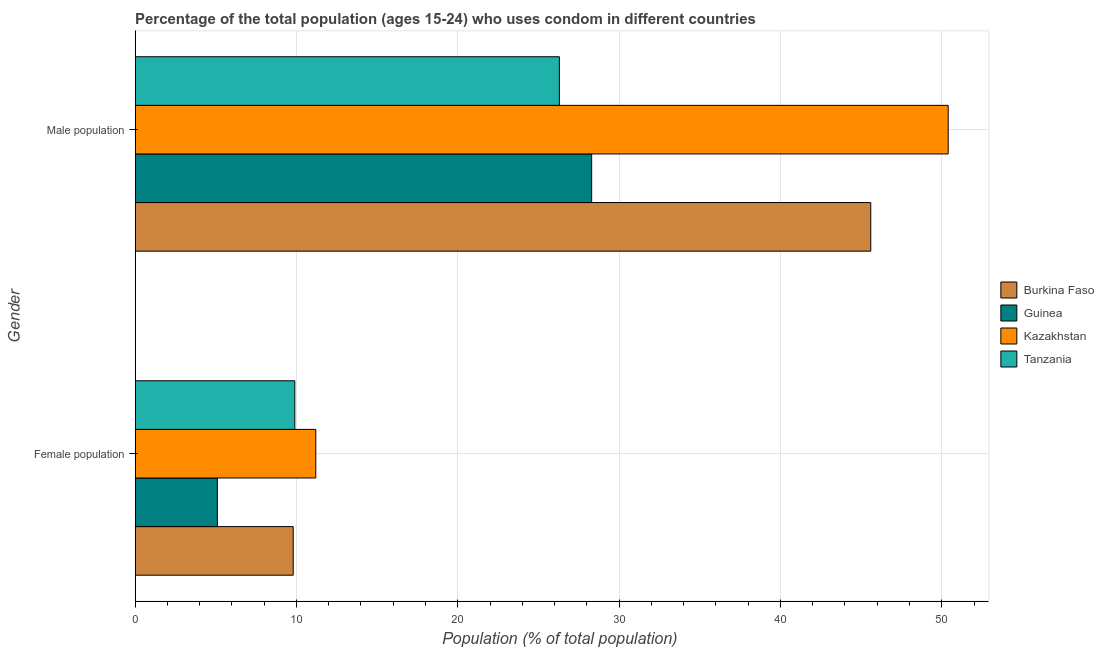How many different coloured bars are there?
Offer a very short reply. 4. How many groups of bars are there?
Keep it short and to the point. 2. Are the number of bars on each tick of the Y-axis equal?
Your answer should be very brief. Yes. What is the label of the 2nd group of bars from the top?
Your answer should be very brief. Female population. What is the male population in Guinea?
Make the answer very short. 28.3. Across all countries, what is the maximum male population?
Give a very brief answer. 50.4. In which country was the male population maximum?
Your answer should be very brief. Kazakhstan. In which country was the male population minimum?
Offer a terse response. Tanzania. What is the total male population in the graph?
Your response must be concise. 150.6. What is the difference between the female population in Burkina Faso and that in Tanzania?
Offer a terse response. -0.1. What is the difference between the female population in Kazakhstan and the male population in Tanzania?
Give a very brief answer. -15.1. What is the average male population per country?
Make the answer very short. 37.65. What is the difference between the male population and female population in Kazakhstan?
Ensure brevity in your answer.  39.2. In how many countries, is the male population greater than 10 %?
Make the answer very short. 4. What is the ratio of the male population in Tanzania to that in Kazakhstan?
Keep it short and to the point. 0.52. Is the male population in Kazakhstan less than that in Tanzania?
Provide a succinct answer. No. In how many countries, is the male population greater than the average male population taken over all countries?
Offer a very short reply. 2. What does the 3rd bar from the top in Male population represents?
Keep it short and to the point. Guinea. What does the 1st bar from the bottom in Male population represents?
Offer a very short reply. Burkina Faso. How many countries are there in the graph?
Your answer should be very brief. 4. Does the graph contain any zero values?
Offer a terse response. No. Where does the legend appear in the graph?
Ensure brevity in your answer.  Center right. How many legend labels are there?
Make the answer very short. 4. How are the legend labels stacked?
Give a very brief answer. Vertical. What is the title of the graph?
Keep it short and to the point. Percentage of the total population (ages 15-24) who uses condom in different countries. What is the label or title of the X-axis?
Ensure brevity in your answer.  Population (% of total population) . What is the label or title of the Y-axis?
Keep it short and to the point. Gender. What is the Population (% of total population)  in Burkina Faso in Female population?
Ensure brevity in your answer.  9.8. What is the Population (% of total population)  of Guinea in Female population?
Offer a very short reply. 5.1. What is the Population (% of total population)  in Kazakhstan in Female population?
Your answer should be very brief. 11.2. What is the Population (% of total population)  in Burkina Faso in Male population?
Offer a very short reply. 45.6. What is the Population (% of total population)  of Guinea in Male population?
Ensure brevity in your answer.  28.3. What is the Population (% of total population)  in Kazakhstan in Male population?
Your answer should be compact. 50.4. What is the Population (% of total population)  in Tanzania in Male population?
Keep it short and to the point. 26.3. Across all Gender, what is the maximum Population (% of total population)  of Burkina Faso?
Offer a very short reply. 45.6. Across all Gender, what is the maximum Population (% of total population)  in Guinea?
Ensure brevity in your answer.  28.3. Across all Gender, what is the maximum Population (% of total population)  in Kazakhstan?
Ensure brevity in your answer.  50.4. Across all Gender, what is the maximum Population (% of total population)  in Tanzania?
Your answer should be very brief. 26.3. Across all Gender, what is the minimum Population (% of total population)  in Burkina Faso?
Your response must be concise. 9.8. Across all Gender, what is the minimum Population (% of total population)  of Guinea?
Make the answer very short. 5.1. Across all Gender, what is the minimum Population (% of total population)  of Tanzania?
Your response must be concise. 9.9. What is the total Population (% of total population)  of Burkina Faso in the graph?
Provide a succinct answer. 55.4. What is the total Population (% of total population)  of Guinea in the graph?
Provide a succinct answer. 33.4. What is the total Population (% of total population)  of Kazakhstan in the graph?
Your response must be concise. 61.6. What is the total Population (% of total population)  in Tanzania in the graph?
Keep it short and to the point. 36.2. What is the difference between the Population (% of total population)  in Burkina Faso in Female population and that in Male population?
Your response must be concise. -35.8. What is the difference between the Population (% of total population)  of Guinea in Female population and that in Male population?
Offer a terse response. -23.2. What is the difference between the Population (% of total population)  in Kazakhstan in Female population and that in Male population?
Your answer should be compact. -39.2. What is the difference between the Population (% of total population)  in Tanzania in Female population and that in Male population?
Give a very brief answer. -16.4. What is the difference between the Population (% of total population)  in Burkina Faso in Female population and the Population (% of total population)  in Guinea in Male population?
Make the answer very short. -18.5. What is the difference between the Population (% of total population)  in Burkina Faso in Female population and the Population (% of total population)  in Kazakhstan in Male population?
Offer a terse response. -40.6. What is the difference between the Population (% of total population)  of Burkina Faso in Female population and the Population (% of total population)  of Tanzania in Male population?
Give a very brief answer. -16.5. What is the difference between the Population (% of total population)  in Guinea in Female population and the Population (% of total population)  in Kazakhstan in Male population?
Keep it short and to the point. -45.3. What is the difference between the Population (% of total population)  of Guinea in Female population and the Population (% of total population)  of Tanzania in Male population?
Offer a terse response. -21.2. What is the difference between the Population (% of total population)  of Kazakhstan in Female population and the Population (% of total population)  of Tanzania in Male population?
Offer a terse response. -15.1. What is the average Population (% of total population)  of Burkina Faso per Gender?
Provide a succinct answer. 27.7. What is the average Population (% of total population)  in Guinea per Gender?
Ensure brevity in your answer.  16.7. What is the average Population (% of total population)  of Kazakhstan per Gender?
Keep it short and to the point. 30.8. What is the average Population (% of total population)  in Tanzania per Gender?
Provide a short and direct response. 18.1. What is the difference between the Population (% of total population)  in Burkina Faso and Population (% of total population)  in Guinea in Female population?
Provide a short and direct response. 4.7. What is the difference between the Population (% of total population)  of Guinea and Population (% of total population)  of Kazakhstan in Female population?
Your response must be concise. -6.1. What is the difference between the Population (% of total population)  in Guinea and Population (% of total population)  in Tanzania in Female population?
Offer a very short reply. -4.8. What is the difference between the Population (% of total population)  of Burkina Faso and Population (% of total population)  of Tanzania in Male population?
Provide a succinct answer. 19.3. What is the difference between the Population (% of total population)  in Guinea and Population (% of total population)  in Kazakhstan in Male population?
Give a very brief answer. -22.1. What is the difference between the Population (% of total population)  of Kazakhstan and Population (% of total population)  of Tanzania in Male population?
Offer a terse response. 24.1. What is the ratio of the Population (% of total population)  in Burkina Faso in Female population to that in Male population?
Provide a short and direct response. 0.21. What is the ratio of the Population (% of total population)  of Guinea in Female population to that in Male population?
Offer a terse response. 0.18. What is the ratio of the Population (% of total population)  of Kazakhstan in Female population to that in Male population?
Ensure brevity in your answer.  0.22. What is the ratio of the Population (% of total population)  of Tanzania in Female population to that in Male population?
Your answer should be compact. 0.38. What is the difference between the highest and the second highest Population (% of total population)  of Burkina Faso?
Provide a short and direct response. 35.8. What is the difference between the highest and the second highest Population (% of total population)  in Guinea?
Provide a short and direct response. 23.2. What is the difference between the highest and the second highest Population (% of total population)  in Kazakhstan?
Your answer should be compact. 39.2. What is the difference between the highest and the second highest Population (% of total population)  in Tanzania?
Your answer should be compact. 16.4. What is the difference between the highest and the lowest Population (% of total population)  in Burkina Faso?
Ensure brevity in your answer.  35.8. What is the difference between the highest and the lowest Population (% of total population)  in Guinea?
Provide a succinct answer. 23.2. What is the difference between the highest and the lowest Population (% of total population)  of Kazakhstan?
Offer a terse response. 39.2. 